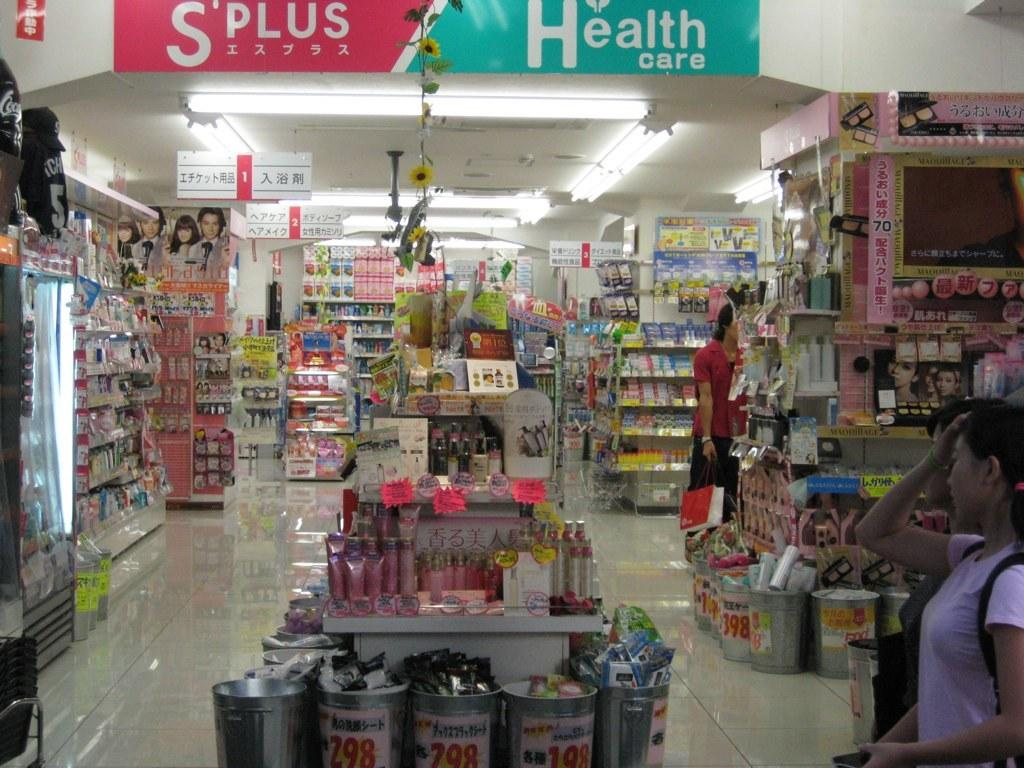What type of establishment is shown in the image? There is a store in the image. Can you describe the people on the right side of the image? Unfortunately, the facts provided do not give any information about the people on the right side of the image. What can be found inside the store? Accessories are placed in racks in the store. How many jellyfish are swimming in the store in the image? There are no jellyfish present in the image; it features a store with accessories placed in racks. What type of order is being followed by the hose in the image? There is no hose present in the image. 